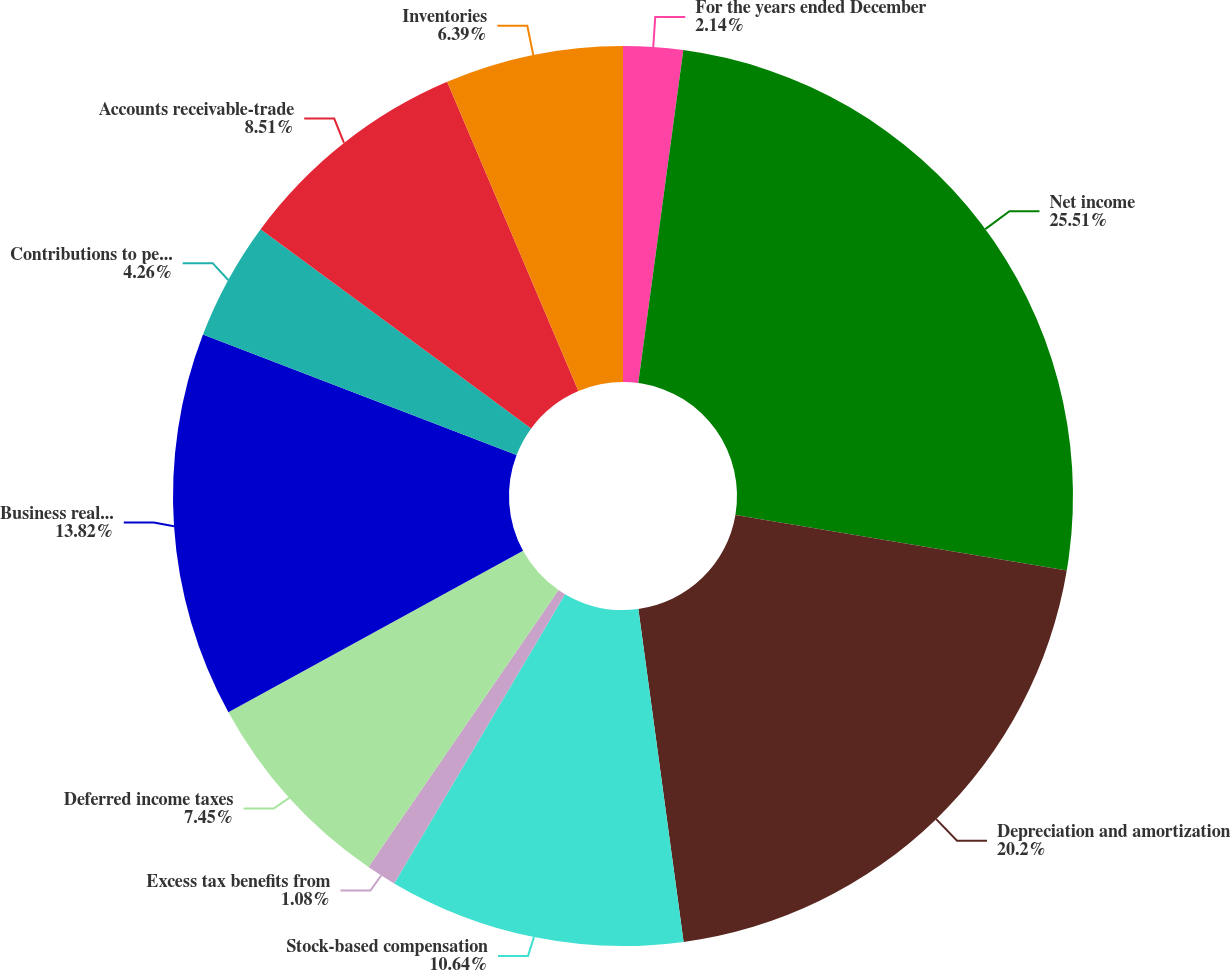<chart> <loc_0><loc_0><loc_500><loc_500><pie_chart><fcel>For the years ended December<fcel>Net income<fcel>Depreciation and amortization<fcel>Stock-based compensation<fcel>Excess tax benefits from<fcel>Deferred income taxes<fcel>Business realignment and<fcel>Contributions to pension plans<fcel>Accounts receivable-trade<fcel>Inventories<nl><fcel>2.14%<fcel>25.51%<fcel>20.2%<fcel>10.64%<fcel>1.08%<fcel>7.45%<fcel>13.82%<fcel>4.26%<fcel>8.51%<fcel>6.39%<nl></chart> 